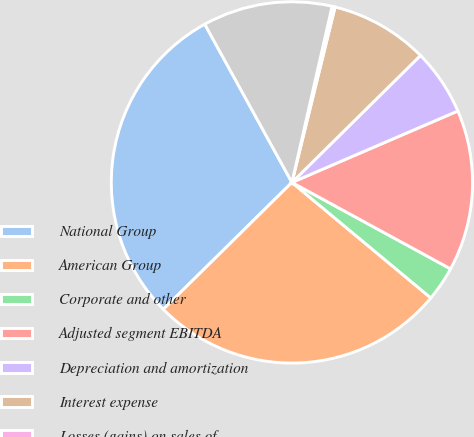Convert chart to OTSL. <chart><loc_0><loc_0><loc_500><loc_500><pie_chart><fcel>National Group<fcel>American Group<fcel>Corporate and other<fcel>Adjusted segment EBITDA<fcel>Depreciation and amortization<fcel>Interest expense<fcel>Losses (gains) on sales of<fcel>Income before income taxes<nl><fcel>29.38%<fcel>26.56%<fcel>3.1%<fcel>14.41%<fcel>5.93%<fcel>8.76%<fcel>0.27%<fcel>11.58%<nl></chart> 